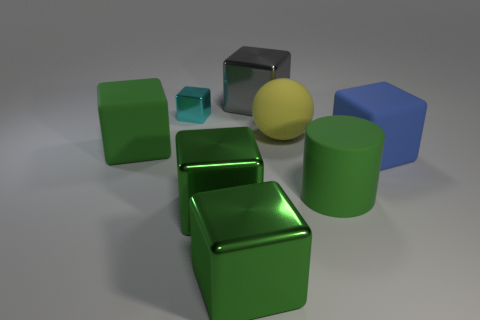Are there any other things that are the same shape as the big yellow matte object?
Offer a terse response. No. Are there any small objects that are to the right of the big green matte object in front of the large green object behind the green matte cylinder?
Your answer should be very brief. No. What number of yellow balls have the same size as the gray shiny thing?
Your answer should be compact. 1. There is a green rubber object to the right of the gray metallic block; does it have the same size as the green matte object that is behind the blue matte object?
Your answer should be compact. Yes. What shape is the big object that is behind the big green rubber cube and on the left side of the large yellow matte sphere?
Provide a succinct answer. Cube. Are there any other big matte cylinders that have the same color as the matte cylinder?
Your answer should be very brief. No. Are there any tiny blue shiny cylinders?
Keep it short and to the point. No. There is a large metallic thing that is behind the yellow ball; what color is it?
Provide a short and direct response. Gray. Do the cyan block and the cube behind the cyan metal thing have the same size?
Your response must be concise. No. There is a cube that is right of the cyan thing and behind the big blue rubber thing; what is its size?
Keep it short and to the point. Large. 